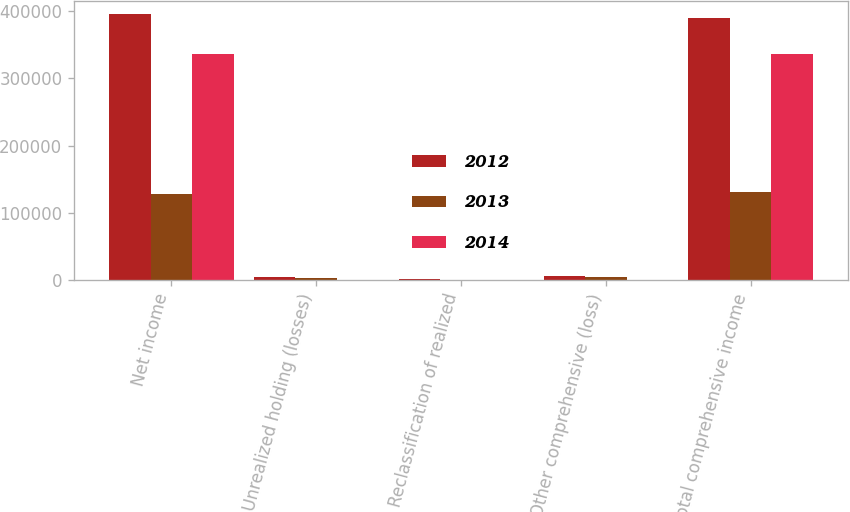<chart> <loc_0><loc_0><loc_500><loc_500><stacked_bar_chart><ecel><fcel>Net income<fcel>Unrealized holding (losses)<fcel>Reclassification of realized<fcel>Other comprehensive (loss)<fcel>Total comprehensive income<nl><fcel>2012<fcel>395281<fcel>4377<fcel>1595<fcel>5884<fcel>389397<nl><fcel>2013<fcel>127389<fcel>2686<fcel>343<fcel>3834<fcel>131223<nl><fcel>2014<fcel>336705<fcel>41<fcel>215<fcel>256<fcel>336449<nl></chart> 